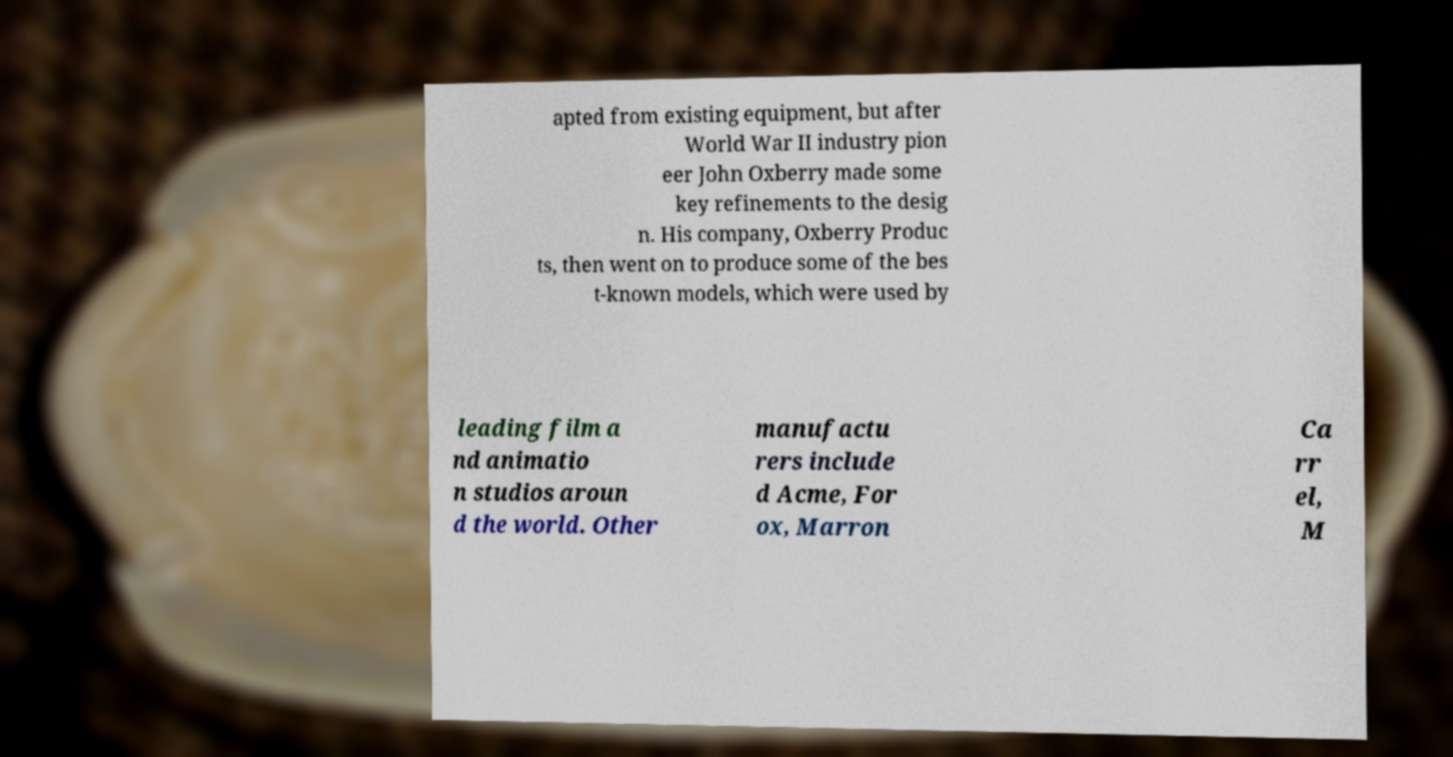Could you assist in decoding the text presented in this image and type it out clearly? apted from existing equipment, but after World War II industry pion eer John Oxberry made some key refinements to the desig n. His company, Oxberry Produc ts, then went on to produce some of the bes t-known models, which were used by leading film a nd animatio n studios aroun d the world. Other manufactu rers include d Acme, For ox, Marron Ca rr el, M 